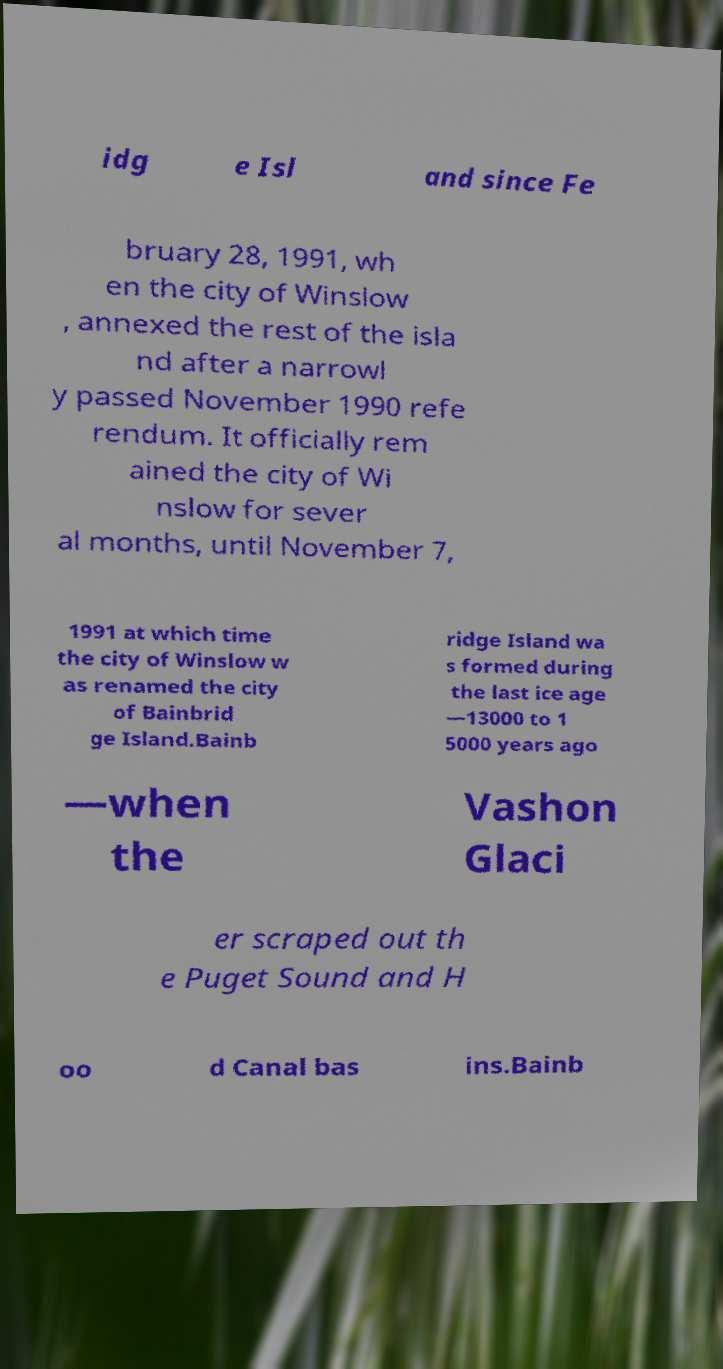Please identify and transcribe the text found in this image. idg e Isl and since Fe bruary 28, 1991, wh en the city of Winslow , annexed the rest of the isla nd after a narrowl y passed November 1990 refe rendum. It officially rem ained the city of Wi nslow for sever al months, until November 7, 1991 at which time the city of Winslow w as renamed the city of Bainbrid ge Island.Bainb ridge Island wa s formed during the last ice age —13000 to 1 5000 years ago —when the Vashon Glaci er scraped out th e Puget Sound and H oo d Canal bas ins.Bainb 